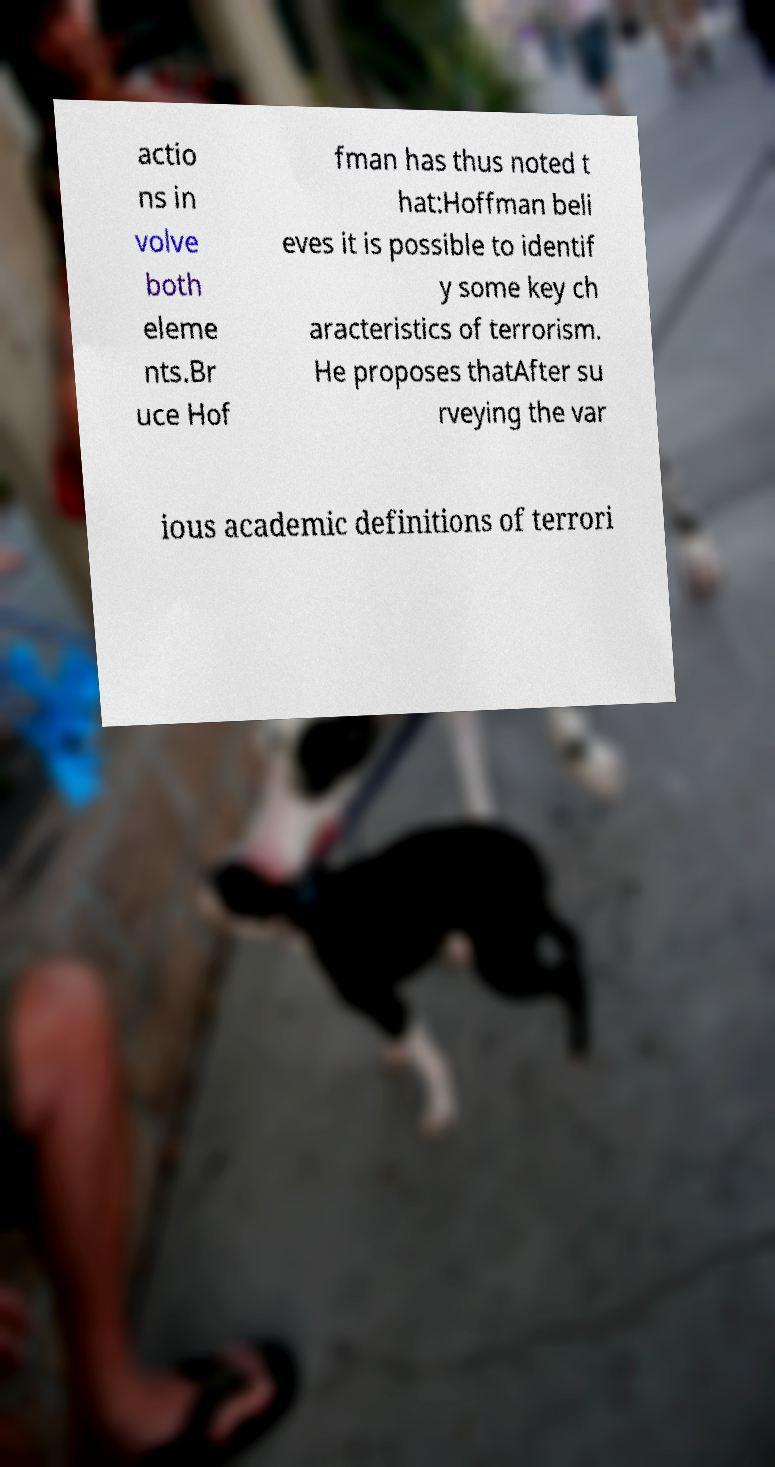Could you extract and type out the text from this image? actio ns in volve both eleme nts.Br uce Hof fman has thus noted t hat:Hoffman beli eves it is possible to identif y some key ch aracteristics of terrorism. He proposes thatAfter su rveying the var ious academic definitions of terrori 